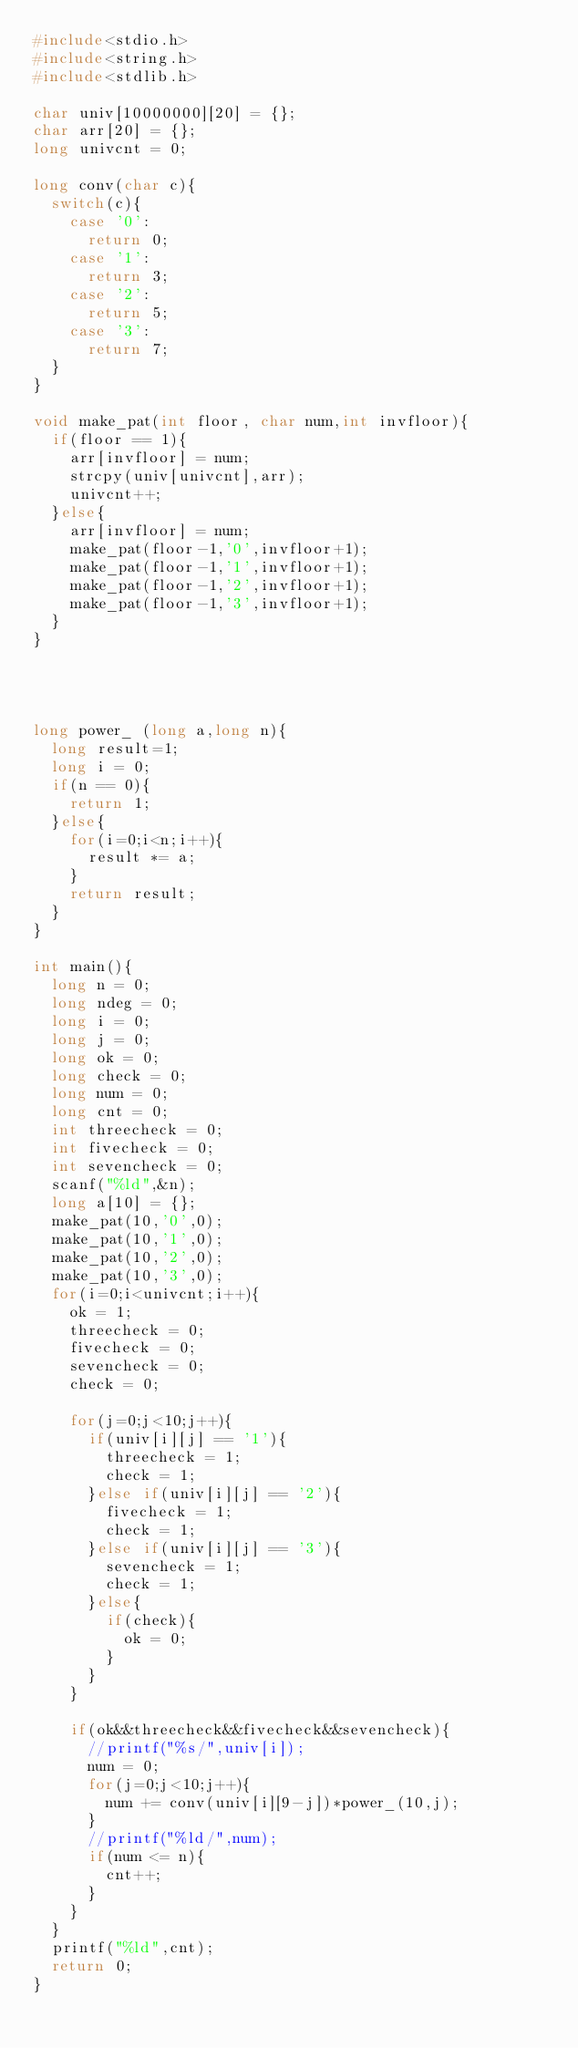Convert code to text. <code><loc_0><loc_0><loc_500><loc_500><_C_>#include<stdio.h>
#include<string.h>
#include<stdlib.h>

char univ[10000000][20] = {};
char arr[20] = {};
long univcnt = 0;

long conv(char c){
  switch(c){
    case '0':
      return 0;
    case '1':
      return 3;
    case '2':
      return 5;
    case '3':
      return 7;
  }
}
      
void make_pat(int floor, char num,int invfloor){
  if(floor == 1){
    arr[invfloor] = num;
    strcpy(univ[univcnt],arr);
    univcnt++;
  }else{
    arr[invfloor] = num;
    make_pat(floor-1,'0',invfloor+1);
    make_pat(floor-1,'1',invfloor+1);
    make_pat(floor-1,'2',invfloor+1);
    make_pat(floor-1,'3',invfloor+1);
  }
}
    
    
  

long power_ (long a,long n){
  long result=1;
  long i = 0;
  if(n == 0){
    return 1;
  }else{
    for(i=0;i<n;i++){
      result *= a;
    }
    return result;
  }
}
    
int main(){
  long n = 0;
  long ndeg = 0;
  long i = 0;
  long j = 0;
  long ok = 0;
  long check = 0;
  long num = 0;
  long cnt = 0;
  int threecheck = 0;
  int fivecheck = 0;
  int sevencheck = 0;
  scanf("%ld",&n);
  long a[10] = {};
  make_pat(10,'0',0);
  make_pat(10,'1',0);
  make_pat(10,'2',0);
  make_pat(10,'3',0);
  for(i=0;i<univcnt;i++){
    ok = 1;
    threecheck = 0;
    fivecheck = 0;
    sevencheck = 0;
    check = 0;
    
    for(j=0;j<10;j++){
      if(univ[i][j] == '1'){
        threecheck = 1;
        check = 1;
      }else if(univ[i][j] == '2'){
        fivecheck = 1;
        check = 1;
      }else if(univ[i][j] == '3'){
        sevencheck = 1;
        check = 1;
      }else{
        if(check){
          ok = 0;
        }
      }
    }
    
    if(ok&&threecheck&&fivecheck&&sevencheck){
      //printf("%s/",univ[i]);
      num = 0;
      for(j=0;j<10;j++){
        num += conv(univ[i][9-j])*power_(10,j);
      }
      //printf("%ld/",num);
      if(num <= n){
        cnt++;
      }
    }
  }
  printf("%ld",cnt);
  return 0;
}
  </code> 